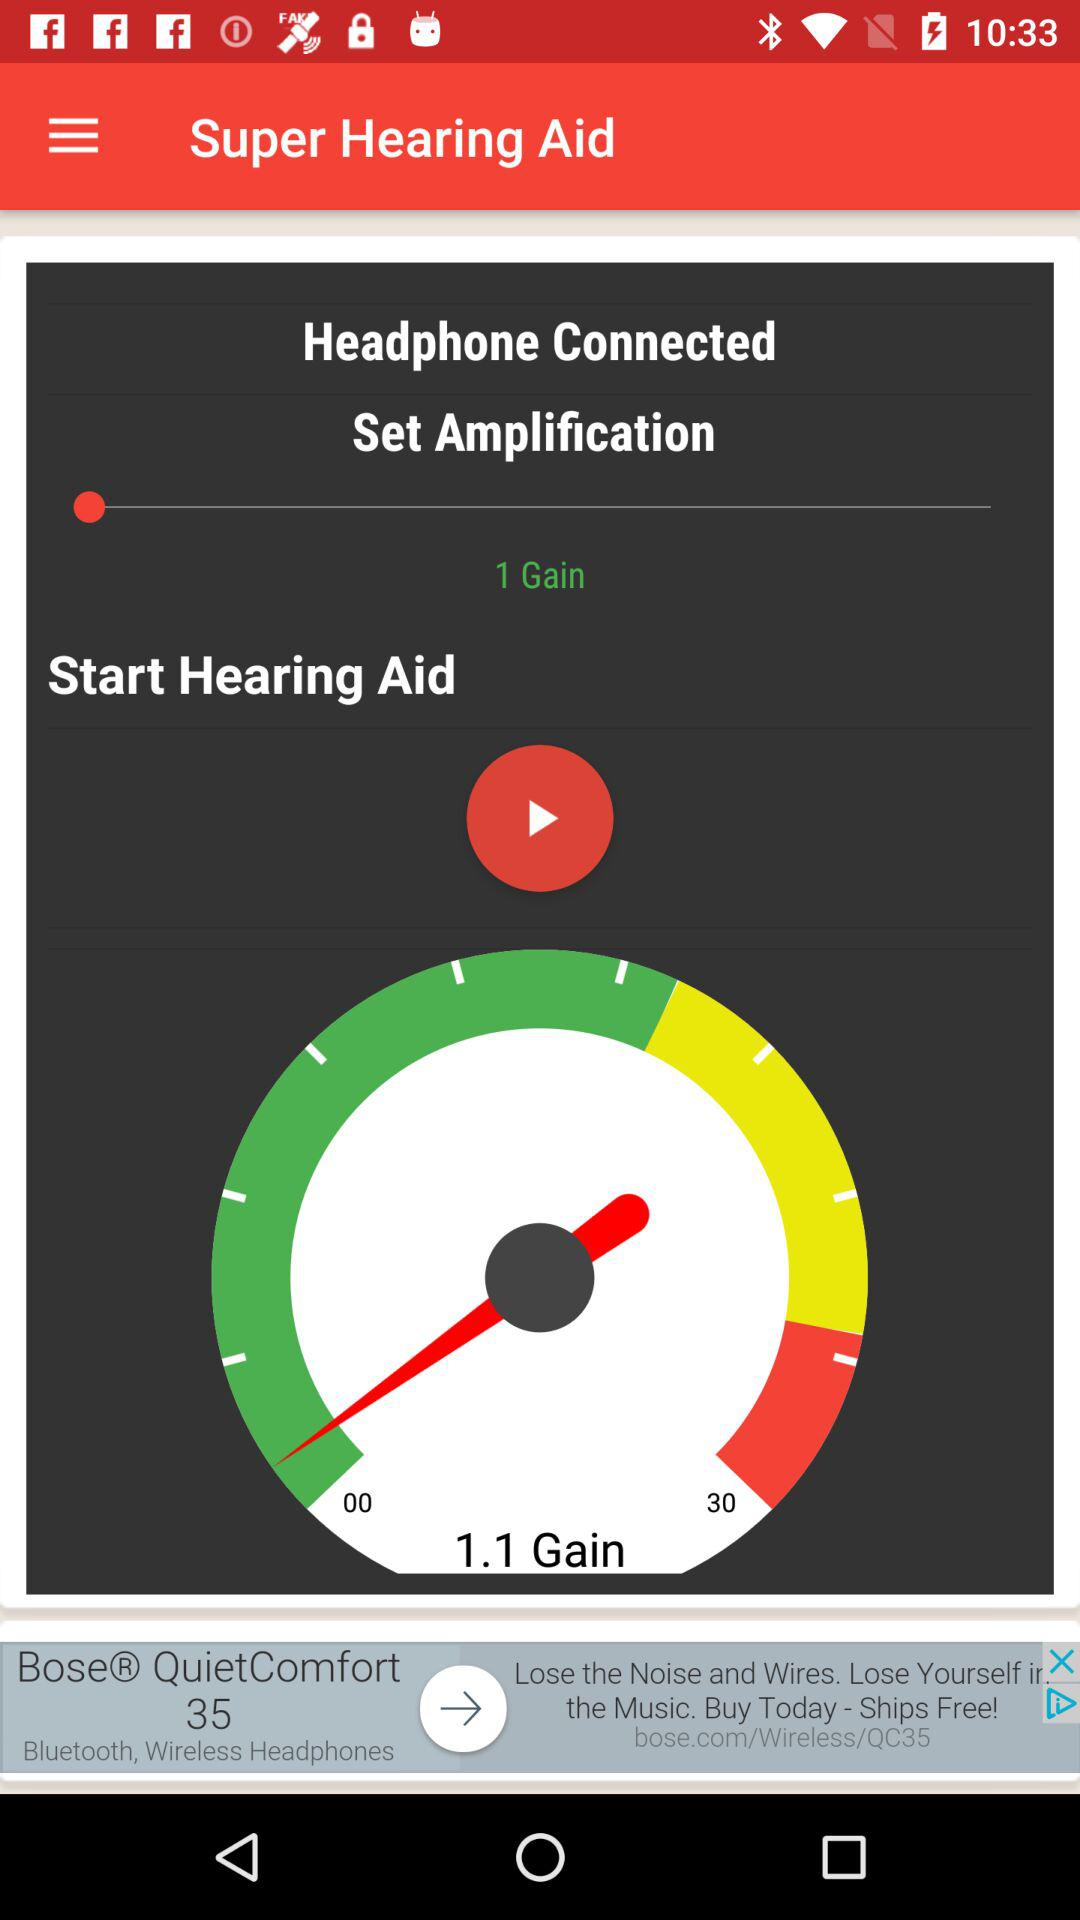What is the maximum number shown on the meter? The maximum number shown on the meter is 30. 